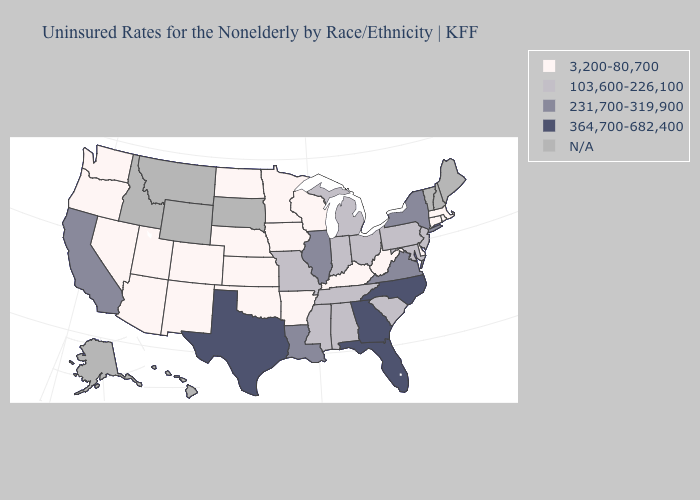What is the lowest value in states that border Oregon?
Concise answer only. 3,200-80,700. Name the states that have a value in the range 103,600-226,100?
Concise answer only. Alabama, Indiana, Maryland, Michigan, Mississippi, Missouri, New Jersey, Ohio, Pennsylvania, South Carolina, Tennessee. What is the lowest value in the Northeast?
Concise answer only. 3,200-80,700. What is the value of Mississippi?
Concise answer only. 103,600-226,100. Name the states that have a value in the range 103,600-226,100?
Write a very short answer. Alabama, Indiana, Maryland, Michigan, Mississippi, Missouri, New Jersey, Ohio, Pennsylvania, South Carolina, Tennessee. Name the states that have a value in the range 231,700-319,900?
Be succinct. California, Illinois, Louisiana, New York, Virginia. What is the value of Delaware?
Be succinct. 3,200-80,700. Does California have the highest value in the West?
Answer briefly. Yes. What is the value of Oklahoma?
Give a very brief answer. 3,200-80,700. Which states have the highest value in the USA?
Keep it brief. Florida, Georgia, North Carolina, Texas. How many symbols are there in the legend?
Be succinct. 5. Name the states that have a value in the range 364,700-682,400?
Short answer required. Florida, Georgia, North Carolina, Texas. Does New York have the lowest value in the USA?
Be succinct. No. Does Massachusetts have the lowest value in the USA?
Give a very brief answer. Yes. 